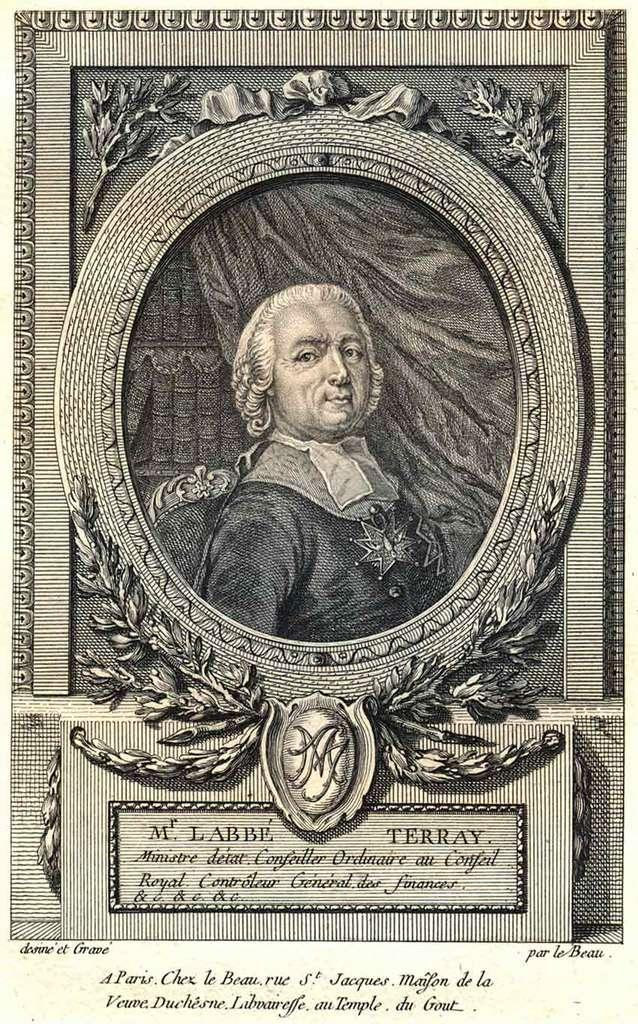Provide a one-sentence caption for the provided image. A historical lithograph of a man features M. Labbe Terra'y. 